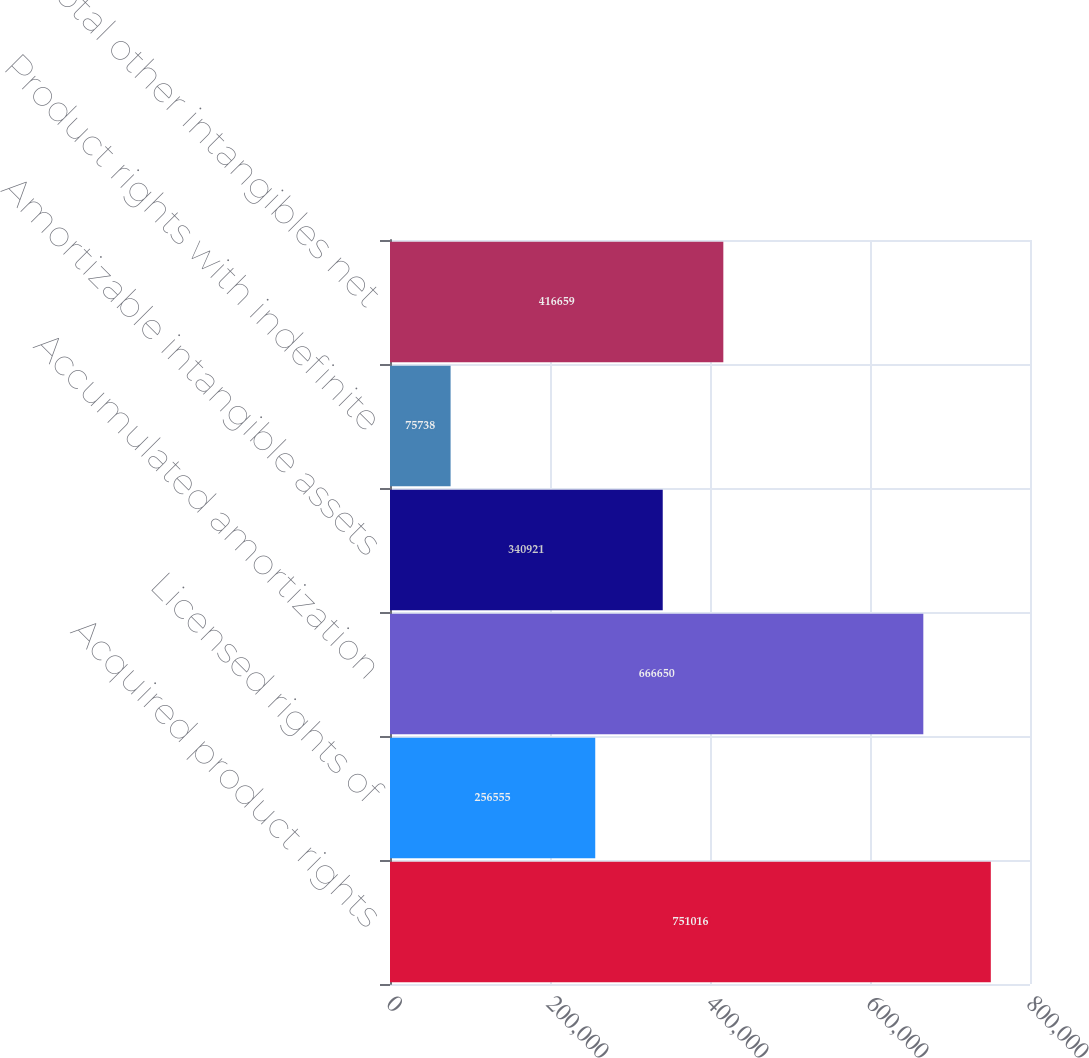Convert chart. <chart><loc_0><loc_0><loc_500><loc_500><bar_chart><fcel>Acquired product rights<fcel>Licensed rights of<fcel>Accumulated amortization<fcel>Amortizable intangible assets<fcel>Product rights with indefinite<fcel>Total other intangibles net<nl><fcel>751016<fcel>256555<fcel>666650<fcel>340921<fcel>75738<fcel>416659<nl></chart> 